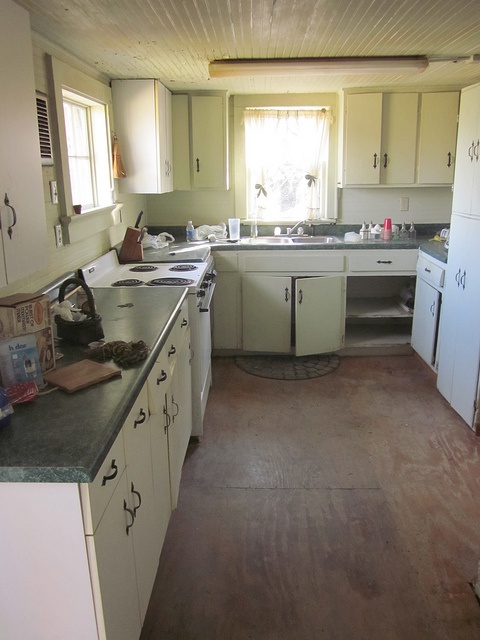Describe the objects in this image and their specific colors. I can see oven in gray, darkgray, black, and lightgray tones, sink in gray, lightgray, and darkgray tones, cup in gray, lightgray, and darkgray tones, bottle in gray and darkgray tones, and cup in gray, lightpink, brown, and darkgray tones in this image. 